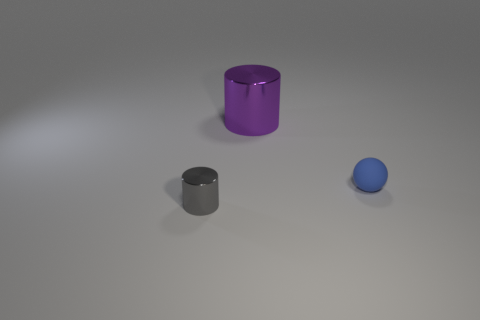Add 2 big yellow metal cylinders. How many objects exist? 5 Subtract all gray cylinders. How many cylinders are left? 1 Subtract all cylinders. How many objects are left? 1 Subtract 1 balls. How many balls are left? 0 Subtract all purple balls. Subtract all green cubes. How many balls are left? 1 Subtract all matte things. Subtract all tiny red blocks. How many objects are left? 2 Add 1 tiny gray objects. How many tiny gray objects are left? 2 Add 3 metal cylinders. How many metal cylinders exist? 5 Subtract 0 blue cylinders. How many objects are left? 3 